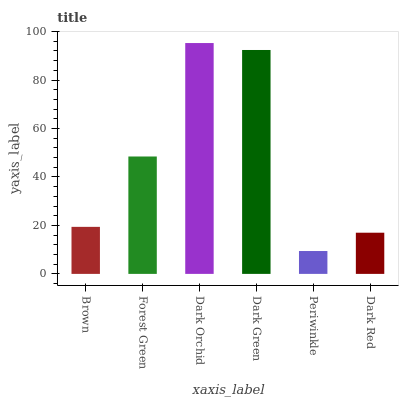Is Periwinkle the minimum?
Answer yes or no. Yes. Is Dark Orchid the maximum?
Answer yes or no. Yes. Is Forest Green the minimum?
Answer yes or no. No. Is Forest Green the maximum?
Answer yes or no. No. Is Forest Green greater than Brown?
Answer yes or no. Yes. Is Brown less than Forest Green?
Answer yes or no. Yes. Is Brown greater than Forest Green?
Answer yes or no. No. Is Forest Green less than Brown?
Answer yes or no. No. Is Forest Green the high median?
Answer yes or no. Yes. Is Brown the low median?
Answer yes or no. Yes. Is Brown the high median?
Answer yes or no. No. Is Dark Green the low median?
Answer yes or no. No. 